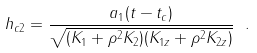Convert formula to latex. <formula><loc_0><loc_0><loc_500><loc_500>h _ { c 2 } = \frac { a _ { 1 } ( t - t _ { c } ) } { \sqrt { ( K _ { 1 } + \rho ^ { 2 } K _ { 2 } ) ( K _ { 1 z } + \rho ^ { 2 } K _ { 2 z } ) } } \ .</formula> 